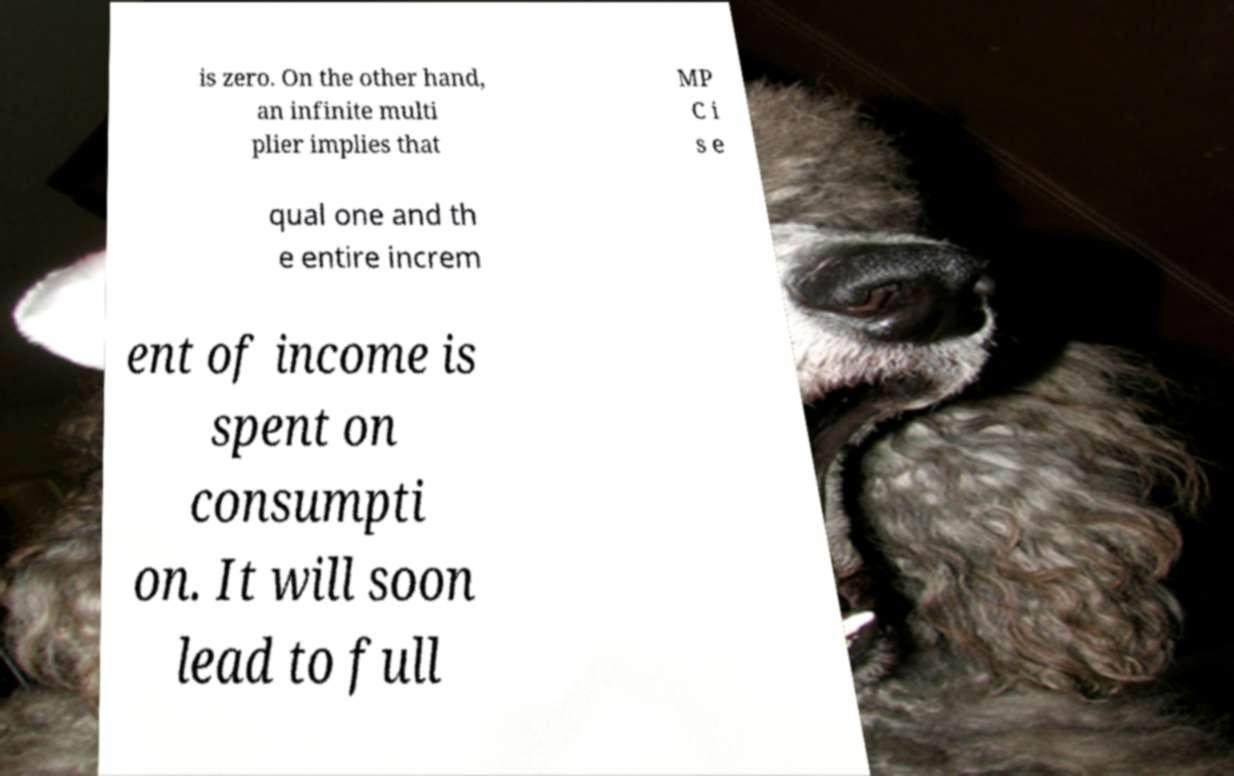I need the written content from this picture converted into text. Can you do that? is zero. On the other hand, an infinite multi plier implies that MP C i s e qual one and th e entire increm ent of income is spent on consumpti on. It will soon lead to full 